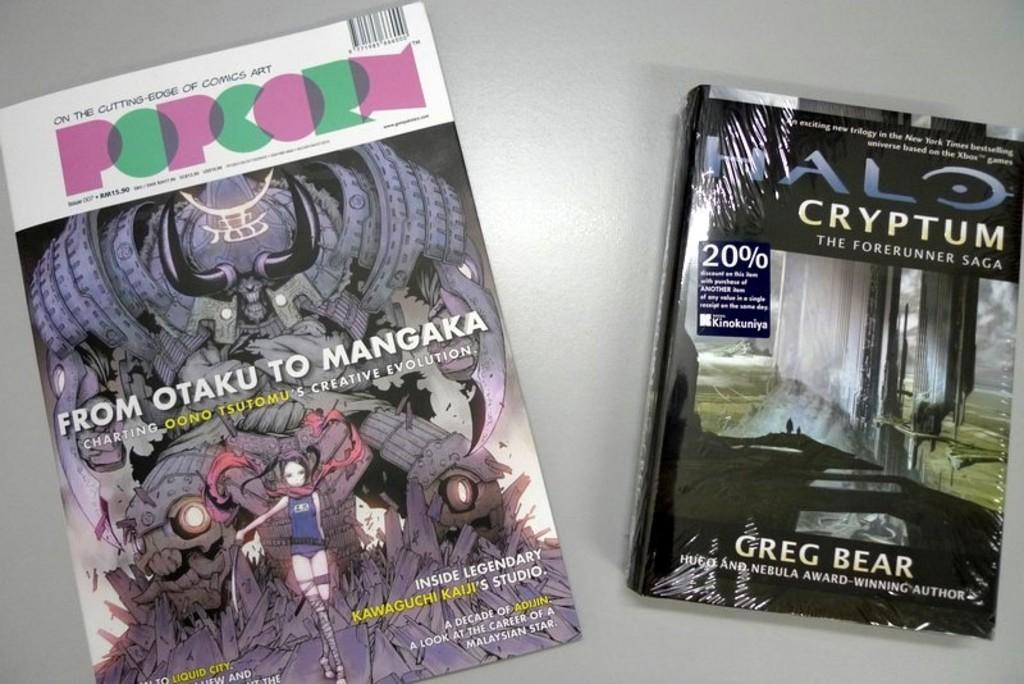How many books are visible in the image? There are two books in the image. What type of images are on the book covers? The book covers have cartoon images. Is there any text on the book covers? Yes, there is text written on the book covers. What is the color of the surface the books are placed on? The books are on a white surface. What type of hair can be seen on the book covers in the image? There is no hair present on the book covers in the image; they have cartoon images and text. 